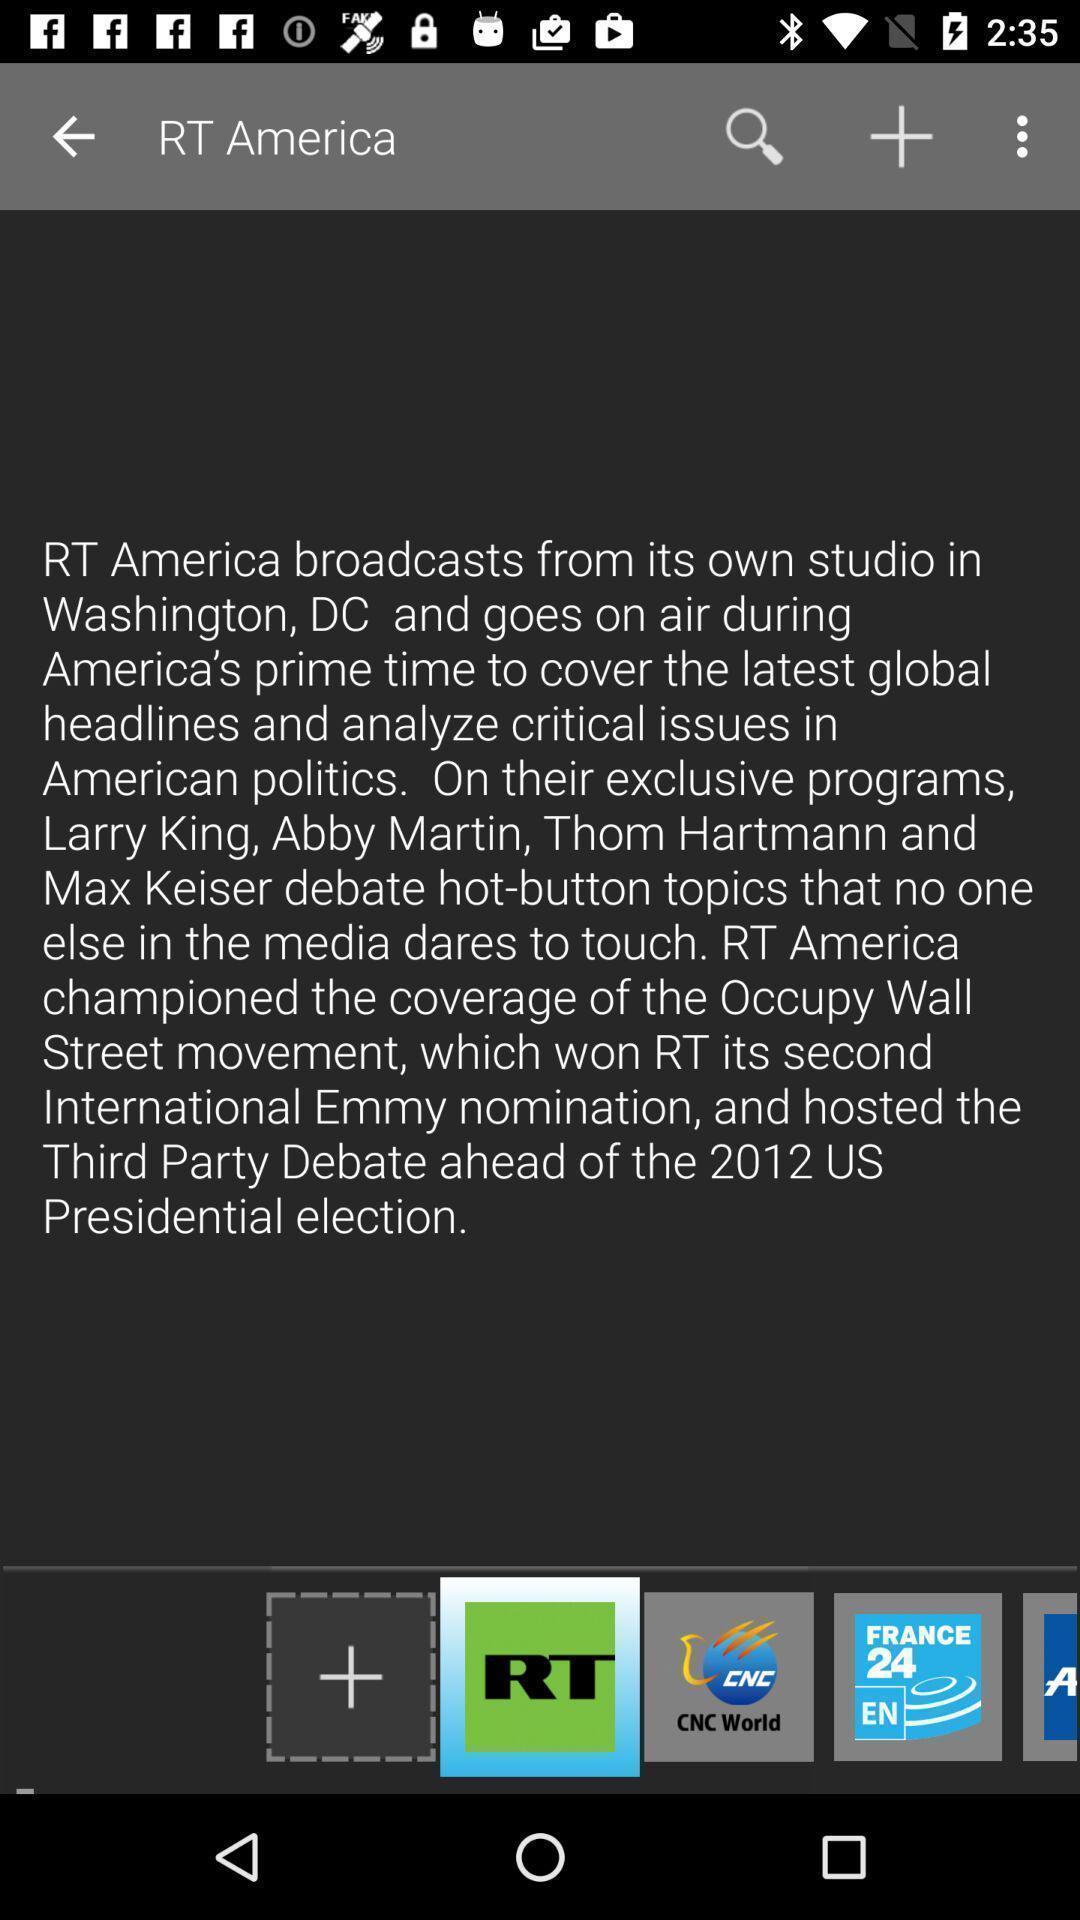Give me a summary of this screen capture. Window displaying an tv app. 